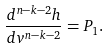Convert formula to latex. <formula><loc_0><loc_0><loc_500><loc_500>\frac { d ^ { n - k - 2 } h } { d v ^ { n - k - 2 } } = P _ { 1 } .</formula> 